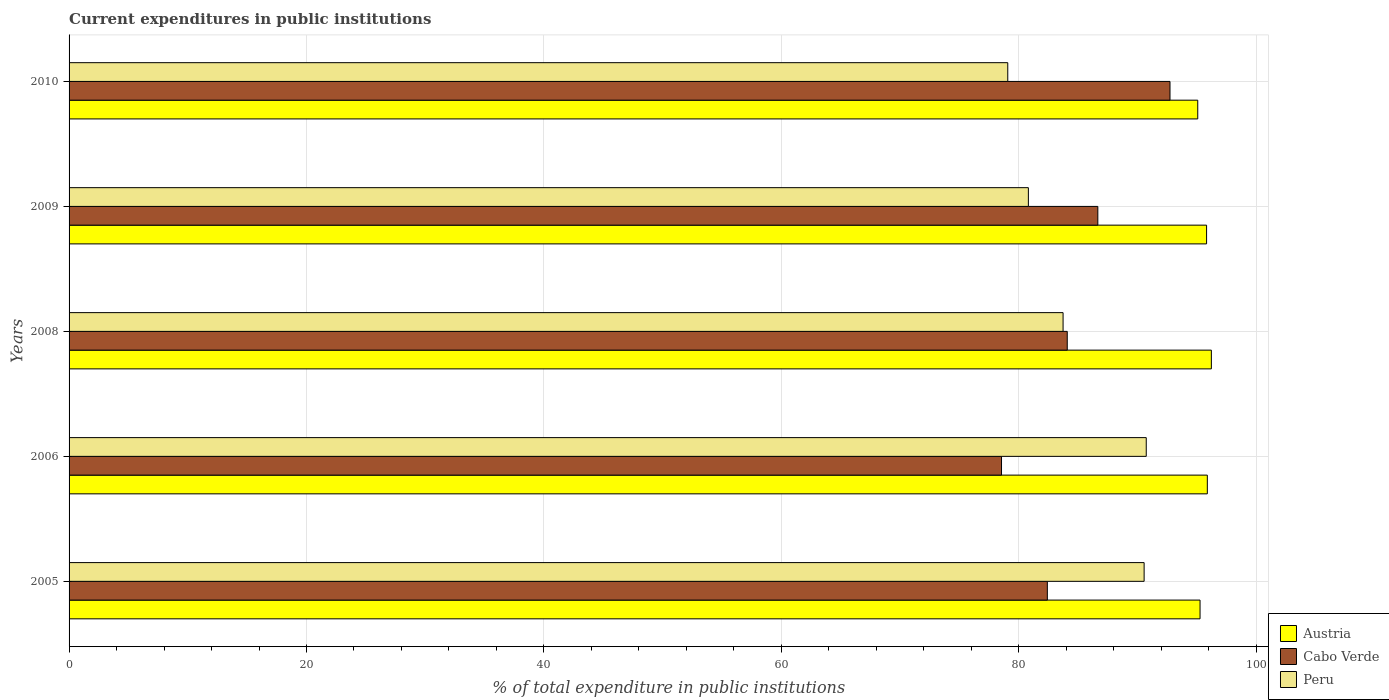How many different coloured bars are there?
Your answer should be very brief. 3. How many bars are there on the 4th tick from the bottom?
Ensure brevity in your answer.  3. What is the current expenditures in public institutions in Peru in 2010?
Provide a succinct answer. 79.08. Across all years, what is the maximum current expenditures in public institutions in Peru?
Offer a very short reply. 90.74. Across all years, what is the minimum current expenditures in public institutions in Peru?
Your response must be concise. 79.08. What is the total current expenditures in public institutions in Austria in the graph?
Your response must be concise. 478.3. What is the difference between the current expenditures in public institutions in Peru in 2005 and that in 2008?
Provide a short and direct response. 6.83. What is the difference between the current expenditures in public institutions in Cabo Verde in 2006 and the current expenditures in public institutions in Peru in 2008?
Offer a very short reply. -5.19. What is the average current expenditures in public institutions in Cabo Verde per year?
Give a very brief answer. 84.89. In the year 2006, what is the difference between the current expenditures in public institutions in Austria and current expenditures in public institutions in Peru?
Keep it short and to the point. 5.15. What is the ratio of the current expenditures in public institutions in Peru in 2005 to that in 2006?
Your answer should be compact. 1. Is the difference between the current expenditures in public institutions in Austria in 2008 and 2010 greater than the difference between the current expenditures in public institutions in Peru in 2008 and 2010?
Ensure brevity in your answer.  No. What is the difference between the highest and the second highest current expenditures in public institutions in Cabo Verde?
Offer a very short reply. 6.08. What is the difference between the highest and the lowest current expenditures in public institutions in Peru?
Provide a succinct answer. 11.67. What does the 2nd bar from the top in 2005 represents?
Your answer should be very brief. Cabo Verde. What does the 2nd bar from the bottom in 2005 represents?
Your answer should be very brief. Cabo Verde. How many bars are there?
Your answer should be very brief. 15. Are all the bars in the graph horizontal?
Make the answer very short. Yes. What is the difference between two consecutive major ticks on the X-axis?
Give a very brief answer. 20. Are the values on the major ticks of X-axis written in scientific E-notation?
Keep it short and to the point. No. Does the graph contain any zero values?
Keep it short and to the point. No. Does the graph contain grids?
Ensure brevity in your answer.  Yes. How many legend labels are there?
Your answer should be compact. 3. What is the title of the graph?
Provide a succinct answer. Current expenditures in public institutions. Does "Low income" appear as one of the legend labels in the graph?
Provide a short and direct response. No. What is the label or title of the X-axis?
Give a very brief answer. % of total expenditure in public institutions. What is the label or title of the Y-axis?
Your answer should be compact. Years. What is the % of total expenditure in public institutions of Austria in 2005?
Provide a short and direct response. 95.28. What is the % of total expenditure in public institutions in Cabo Verde in 2005?
Ensure brevity in your answer.  82.41. What is the % of total expenditure in public institutions of Peru in 2005?
Ensure brevity in your answer.  90.56. What is the % of total expenditure in public institutions in Austria in 2006?
Ensure brevity in your answer.  95.89. What is the % of total expenditure in public institutions of Cabo Verde in 2006?
Give a very brief answer. 78.55. What is the % of total expenditure in public institutions of Peru in 2006?
Offer a very short reply. 90.74. What is the % of total expenditure in public institutions in Austria in 2008?
Your answer should be very brief. 96.23. What is the % of total expenditure in public institutions of Cabo Verde in 2008?
Provide a succinct answer. 84.09. What is the % of total expenditure in public institutions of Peru in 2008?
Keep it short and to the point. 83.74. What is the % of total expenditure in public institutions of Austria in 2009?
Keep it short and to the point. 95.83. What is the % of total expenditure in public institutions of Cabo Verde in 2009?
Offer a terse response. 86.66. What is the % of total expenditure in public institutions of Peru in 2009?
Offer a terse response. 80.81. What is the % of total expenditure in public institutions of Austria in 2010?
Keep it short and to the point. 95.08. What is the % of total expenditure in public institutions of Cabo Verde in 2010?
Ensure brevity in your answer.  92.74. What is the % of total expenditure in public institutions in Peru in 2010?
Provide a short and direct response. 79.08. Across all years, what is the maximum % of total expenditure in public institutions in Austria?
Your answer should be compact. 96.23. Across all years, what is the maximum % of total expenditure in public institutions in Cabo Verde?
Your answer should be compact. 92.74. Across all years, what is the maximum % of total expenditure in public institutions of Peru?
Your answer should be compact. 90.74. Across all years, what is the minimum % of total expenditure in public institutions of Austria?
Make the answer very short. 95.08. Across all years, what is the minimum % of total expenditure in public institutions in Cabo Verde?
Ensure brevity in your answer.  78.55. Across all years, what is the minimum % of total expenditure in public institutions in Peru?
Give a very brief answer. 79.08. What is the total % of total expenditure in public institutions in Austria in the graph?
Keep it short and to the point. 478.3. What is the total % of total expenditure in public institutions in Cabo Verde in the graph?
Your answer should be very brief. 424.46. What is the total % of total expenditure in public institutions in Peru in the graph?
Your answer should be very brief. 424.94. What is the difference between the % of total expenditure in public institutions in Austria in 2005 and that in 2006?
Your answer should be very brief. -0.61. What is the difference between the % of total expenditure in public institutions in Cabo Verde in 2005 and that in 2006?
Ensure brevity in your answer.  3.86. What is the difference between the % of total expenditure in public institutions of Peru in 2005 and that in 2006?
Make the answer very short. -0.18. What is the difference between the % of total expenditure in public institutions in Austria in 2005 and that in 2008?
Make the answer very short. -0.95. What is the difference between the % of total expenditure in public institutions of Cabo Verde in 2005 and that in 2008?
Make the answer very short. -1.68. What is the difference between the % of total expenditure in public institutions in Peru in 2005 and that in 2008?
Make the answer very short. 6.83. What is the difference between the % of total expenditure in public institutions in Austria in 2005 and that in 2009?
Your answer should be very brief. -0.55. What is the difference between the % of total expenditure in public institutions of Cabo Verde in 2005 and that in 2009?
Your answer should be compact. -4.25. What is the difference between the % of total expenditure in public institutions of Peru in 2005 and that in 2009?
Ensure brevity in your answer.  9.75. What is the difference between the % of total expenditure in public institutions in Austria in 2005 and that in 2010?
Keep it short and to the point. 0.19. What is the difference between the % of total expenditure in public institutions of Cabo Verde in 2005 and that in 2010?
Give a very brief answer. -10.33. What is the difference between the % of total expenditure in public institutions in Peru in 2005 and that in 2010?
Keep it short and to the point. 11.49. What is the difference between the % of total expenditure in public institutions of Austria in 2006 and that in 2008?
Offer a terse response. -0.34. What is the difference between the % of total expenditure in public institutions of Cabo Verde in 2006 and that in 2008?
Your answer should be very brief. -5.54. What is the difference between the % of total expenditure in public institutions of Peru in 2006 and that in 2008?
Provide a succinct answer. 7.01. What is the difference between the % of total expenditure in public institutions in Austria in 2006 and that in 2009?
Offer a terse response. 0.06. What is the difference between the % of total expenditure in public institutions of Cabo Verde in 2006 and that in 2009?
Offer a very short reply. -8.11. What is the difference between the % of total expenditure in public institutions in Peru in 2006 and that in 2009?
Give a very brief answer. 9.93. What is the difference between the % of total expenditure in public institutions in Austria in 2006 and that in 2010?
Make the answer very short. 0.81. What is the difference between the % of total expenditure in public institutions of Cabo Verde in 2006 and that in 2010?
Offer a terse response. -14.19. What is the difference between the % of total expenditure in public institutions in Peru in 2006 and that in 2010?
Provide a succinct answer. 11.67. What is the difference between the % of total expenditure in public institutions in Austria in 2008 and that in 2009?
Make the answer very short. 0.4. What is the difference between the % of total expenditure in public institutions in Cabo Verde in 2008 and that in 2009?
Keep it short and to the point. -2.58. What is the difference between the % of total expenditure in public institutions of Peru in 2008 and that in 2009?
Keep it short and to the point. 2.92. What is the difference between the % of total expenditure in public institutions in Austria in 2008 and that in 2010?
Offer a very short reply. 1.15. What is the difference between the % of total expenditure in public institutions in Cabo Verde in 2008 and that in 2010?
Offer a very short reply. -8.66. What is the difference between the % of total expenditure in public institutions of Peru in 2008 and that in 2010?
Your response must be concise. 4.66. What is the difference between the % of total expenditure in public institutions of Austria in 2009 and that in 2010?
Make the answer very short. 0.74. What is the difference between the % of total expenditure in public institutions of Cabo Verde in 2009 and that in 2010?
Offer a very short reply. -6.08. What is the difference between the % of total expenditure in public institutions in Peru in 2009 and that in 2010?
Your response must be concise. 1.74. What is the difference between the % of total expenditure in public institutions in Austria in 2005 and the % of total expenditure in public institutions in Cabo Verde in 2006?
Offer a very short reply. 16.72. What is the difference between the % of total expenditure in public institutions of Austria in 2005 and the % of total expenditure in public institutions of Peru in 2006?
Offer a very short reply. 4.53. What is the difference between the % of total expenditure in public institutions of Cabo Verde in 2005 and the % of total expenditure in public institutions of Peru in 2006?
Provide a short and direct response. -8.33. What is the difference between the % of total expenditure in public institutions in Austria in 2005 and the % of total expenditure in public institutions in Cabo Verde in 2008?
Provide a succinct answer. 11.19. What is the difference between the % of total expenditure in public institutions of Austria in 2005 and the % of total expenditure in public institutions of Peru in 2008?
Give a very brief answer. 11.54. What is the difference between the % of total expenditure in public institutions in Cabo Verde in 2005 and the % of total expenditure in public institutions in Peru in 2008?
Offer a terse response. -1.33. What is the difference between the % of total expenditure in public institutions in Austria in 2005 and the % of total expenditure in public institutions in Cabo Verde in 2009?
Provide a succinct answer. 8.61. What is the difference between the % of total expenditure in public institutions of Austria in 2005 and the % of total expenditure in public institutions of Peru in 2009?
Your response must be concise. 14.46. What is the difference between the % of total expenditure in public institutions in Cabo Verde in 2005 and the % of total expenditure in public institutions in Peru in 2009?
Make the answer very short. 1.6. What is the difference between the % of total expenditure in public institutions of Austria in 2005 and the % of total expenditure in public institutions of Cabo Verde in 2010?
Provide a short and direct response. 2.53. What is the difference between the % of total expenditure in public institutions of Austria in 2005 and the % of total expenditure in public institutions of Peru in 2010?
Your response must be concise. 16.2. What is the difference between the % of total expenditure in public institutions in Cabo Verde in 2005 and the % of total expenditure in public institutions in Peru in 2010?
Provide a short and direct response. 3.33. What is the difference between the % of total expenditure in public institutions of Austria in 2006 and the % of total expenditure in public institutions of Cabo Verde in 2008?
Ensure brevity in your answer.  11.8. What is the difference between the % of total expenditure in public institutions of Austria in 2006 and the % of total expenditure in public institutions of Peru in 2008?
Offer a terse response. 12.15. What is the difference between the % of total expenditure in public institutions of Cabo Verde in 2006 and the % of total expenditure in public institutions of Peru in 2008?
Keep it short and to the point. -5.19. What is the difference between the % of total expenditure in public institutions of Austria in 2006 and the % of total expenditure in public institutions of Cabo Verde in 2009?
Give a very brief answer. 9.22. What is the difference between the % of total expenditure in public institutions in Austria in 2006 and the % of total expenditure in public institutions in Peru in 2009?
Your answer should be very brief. 15.08. What is the difference between the % of total expenditure in public institutions in Cabo Verde in 2006 and the % of total expenditure in public institutions in Peru in 2009?
Your response must be concise. -2.26. What is the difference between the % of total expenditure in public institutions of Austria in 2006 and the % of total expenditure in public institutions of Cabo Verde in 2010?
Your response must be concise. 3.14. What is the difference between the % of total expenditure in public institutions of Austria in 2006 and the % of total expenditure in public institutions of Peru in 2010?
Offer a terse response. 16.81. What is the difference between the % of total expenditure in public institutions in Cabo Verde in 2006 and the % of total expenditure in public institutions in Peru in 2010?
Give a very brief answer. -0.53. What is the difference between the % of total expenditure in public institutions in Austria in 2008 and the % of total expenditure in public institutions in Cabo Verde in 2009?
Provide a succinct answer. 9.56. What is the difference between the % of total expenditure in public institutions in Austria in 2008 and the % of total expenditure in public institutions in Peru in 2009?
Your answer should be very brief. 15.42. What is the difference between the % of total expenditure in public institutions of Cabo Verde in 2008 and the % of total expenditure in public institutions of Peru in 2009?
Keep it short and to the point. 3.27. What is the difference between the % of total expenditure in public institutions of Austria in 2008 and the % of total expenditure in public institutions of Cabo Verde in 2010?
Make the answer very short. 3.48. What is the difference between the % of total expenditure in public institutions in Austria in 2008 and the % of total expenditure in public institutions in Peru in 2010?
Give a very brief answer. 17.15. What is the difference between the % of total expenditure in public institutions of Cabo Verde in 2008 and the % of total expenditure in public institutions of Peru in 2010?
Give a very brief answer. 5.01. What is the difference between the % of total expenditure in public institutions in Austria in 2009 and the % of total expenditure in public institutions in Cabo Verde in 2010?
Make the answer very short. 3.08. What is the difference between the % of total expenditure in public institutions of Austria in 2009 and the % of total expenditure in public institutions of Peru in 2010?
Your answer should be very brief. 16.75. What is the difference between the % of total expenditure in public institutions of Cabo Verde in 2009 and the % of total expenditure in public institutions of Peru in 2010?
Provide a succinct answer. 7.59. What is the average % of total expenditure in public institutions in Austria per year?
Provide a short and direct response. 95.66. What is the average % of total expenditure in public institutions of Cabo Verde per year?
Offer a very short reply. 84.89. What is the average % of total expenditure in public institutions of Peru per year?
Offer a very short reply. 84.99. In the year 2005, what is the difference between the % of total expenditure in public institutions in Austria and % of total expenditure in public institutions in Cabo Verde?
Provide a succinct answer. 12.86. In the year 2005, what is the difference between the % of total expenditure in public institutions of Austria and % of total expenditure in public institutions of Peru?
Offer a very short reply. 4.71. In the year 2005, what is the difference between the % of total expenditure in public institutions in Cabo Verde and % of total expenditure in public institutions in Peru?
Give a very brief answer. -8.15. In the year 2006, what is the difference between the % of total expenditure in public institutions of Austria and % of total expenditure in public institutions of Cabo Verde?
Your response must be concise. 17.34. In the year 2006, what is the difference between the % of total expenditure in public institutions in Austria and % of total expenditure in public institutions in Peru?
Your response must be concise. 5.15. In the year 2006, what is the difference between the % of total expenditure in public institutions of Cabo Verde and % of total expenditure in public institutions of Peru?
Provide a short and direct response. -12.19. In the year 2008, what is the difference between the % of total expenditure in public institutions in Austria and % of total expenditure in public institutions in Cabo Verde?
Provide a short and direct response. 12.14. In the year 2008, what is the difference between the % of total expenditure in public institutions in Austria and % of total expenditure in public institutions in Peru?
Give a very brief answer. 12.49. In the year 2008, what is the difference between the % of total expenditure in public institutions of Cabo Verde and % of total expenditure in public institutions of Peru?
Provide a short and direct response. 0.35. In the year 2009, what is the difference between the % of total expenditure in public institutions of Austria and % of total expenditure in public institutions of Cabo Verde?
Your response must be concise. 9.16. In the year 2009, what is the difference between the % of total expenditure in public institutions of Austria and % of total expenditure in public institutions of Peru?
Your answer should be compact. 15.01. In the year 2009, what is the difference between the % of total expenditure in public institutions of Cabo Verde and % of total expenditure in public institutions of Peru?
Your answer should be compact. 5.85. In the year 2010, what is the difference between the % of total expenditure in public institutions in Austria and % of total expenditure in public institutions in Cabo Verde?
Your response must be concise. 2.34. In the year 2010, what is the difference between the % of total expenditure in public institutions of Austria and % of total expenditure in public institutions of Peru?
Offer a terse response. 16. In the year 2010, what is the difference between the % of total expenditure in public institutions in Cabo Verde and % of total expenditure in public institutions in Peru?
Your answer should be compact. 13.67. What is the ratio of the % of total expenditure in public institutions of Cabo Verde in 2005 to that in 2006?
Give a very brief answer. 1.05. What is the ratio of the % of total expenditure in public institutions in Austria in 2005 to that in 2008?
Make the answer very short. 0.99. What is the ratio of the % of total expenditure in public institutions in Cabo Verde in 2005 to that in 2008?
Provide a short and direct response. 0.98. What is the ratio of the % of total expenditure in public institutions in Peru in 2005 to that in 2008?
Offer a terse response. 1.08. What is the ratio of the % of total expenditure in public institutions of Austria in 2005 to that in 2009?
Ensure brevity in your answer.  0.99. What is the ratio of the % of total expenditure in public institutions in Cabo Verde in 2005 to that in 2009?
Your answer should be very brief. 0.95. What is the ratio of the % of total expenditure in public institutions of Peru in 2005 to that in 2009?
Provide a succinct answer. 1.12. What is the ratio of the % of total expenditure in public institutions in Austria in 2005 to that in 2010?
Provide a short and direct response. 1. What is the ratio of the % of total expenditure in public institutions of Cabo Verde in 2005 to that in 2010?
Offer a very short reply. 0.89. What is the ratio of the % of total expenditure in public institutions of Peru in 2005 to that in 2010?
Provide a short and direct response. 1.15. What is the ratio of the % of total expenditure in public institutions in Austria in 2006 to that in 2008?
Give a very brief answer. 1. What is the ratio of the % of total expenditure in public institutions in Cabo Verde in 2006 to that in 2008?
Give a very brief answer. 0.93. What is the ratio of the % of total expenditure in public institutions of Peru in 2006 to that in 2008?
Keep it short and to the point. 1.08. What is the ratio of the % of total expenditure in public institutions of Cabo Verde in 2006 to that in 2009?
Your answer should be very brief. 0.91. What is the ratio of the % of total expenditure in public institutions of Peru in 2006 to that in 2009?
Ensure brevity in your answer.  1.12. What is the ratio of the % of total expenditure in public institutions of Austria in 2006 to that in 2010?
Provide a succinct answer. 1.01. What is the ratio of the % of total expenditure in public institutions of Cabo Verde in 2006 to that in 2010?
Your answer should be compact. 0.85. What is the ratio of the % of total expenditure in public institutions of Peru in 2006 to that in 2010?
Keep it short and to the point. 1.15. What is the ratio of the % of total expenditure in public institutions of Cabo Verde in 2008 to that in 2009?
Offer a very short reply. 0.97. What is the ratio of the % of total expenditure in public institutions of Peru in 2008 to that in 2009?
Your answer should be compact. 1.04. What is the ratio of the % of total expenditure in public institutions in Austria in 2008 to that in 2010?
Keep it short and to the point. 1.01. What is the ratio of the % of total expenditure in public institutions in Cabo Verde in 2008 to that in 2010?
Provide a succinct answer. 0.91. What is the ratio of the % of total expenditure in public institutions of Peru in 2008 to that in 2010?
Offer a very short reply. 1.06. What is the ratio of the % of total expenditure in public institutions of Austria in 2009 to that in 2010?
Offer a terse response. 1.01. What is the ratio of the % of total expenditure in public institutions of Cabo Verde in 2009 to that in 2010?
Your response must be concise. 0.93. What is the ratio of the % of total expenditure in public institutions of Peru in 2009 to that in 2010?
Provide a succinct answer. 1.02. What is the difference between the highest and the second highest % of total expenditure in public institutions of Austria?
Provide a succinct answer. 0.34. What is the difference between the highest and the second highest % of total expenditure in public institutions in Cabo Verde?
Make the answer very short. 6.08. What is the difference between the highest and the second highest % of total expenditure in public institutions of Peru?
Give a very brief answer. 0.18. What is the difference between the highest and the lowest % of total expenditure in public institutions of Austria?
Offer a very short reply. 1.15. What is the difference between the highest and the lowest % of total expenditure in public institutions of Cabo Verde?
Offer a very short reply. 14.19. What is the difference between the highest and the lowest % of total expenditure in public institutions of Peru?
Provide a succinct answer. 11.67. 